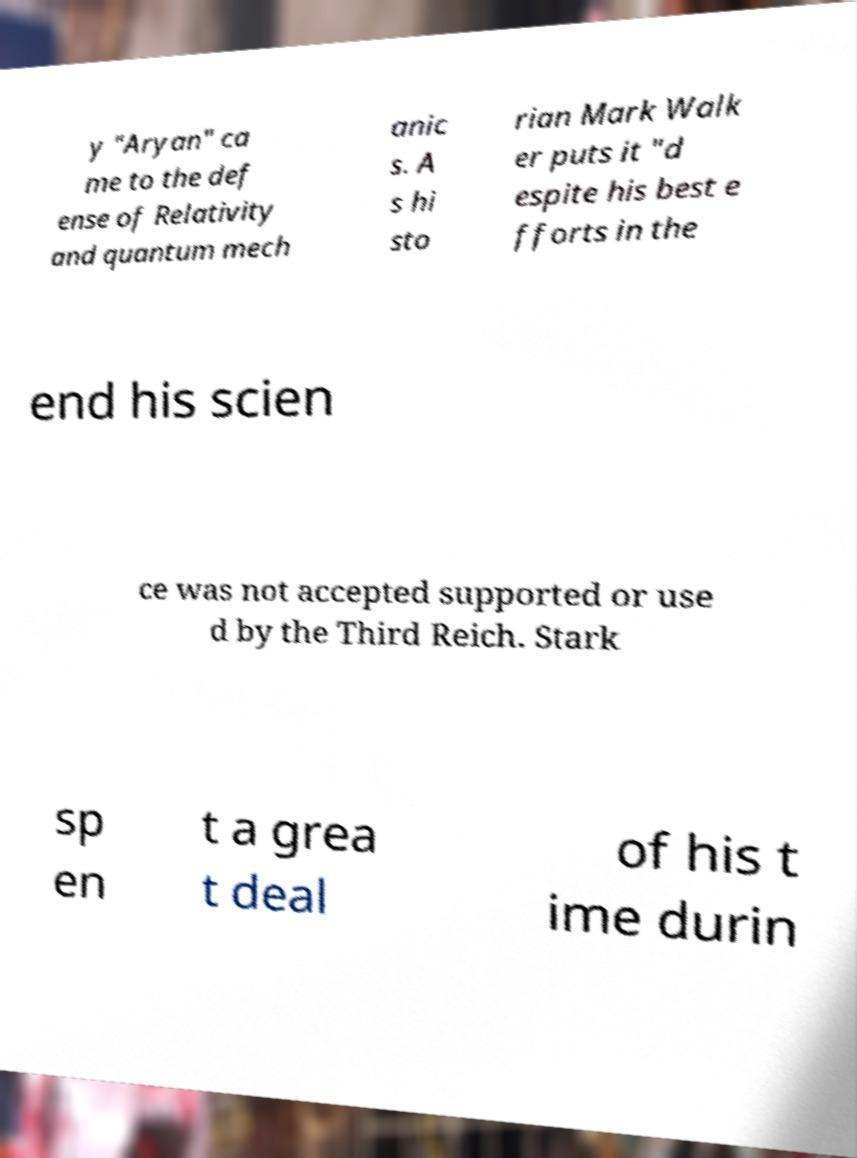Please read and relay the text visible in this image. What does it say? y "Aryan" ca me to the def ense of Relativity and quantum mech anic s. A s hi sto rian Mark Walk er puts it "d espite his best e fforts in the end his scien ce was not accepted supported or use d by the Third Reich. Stark sp en t a grea t deal of his t ime durin 